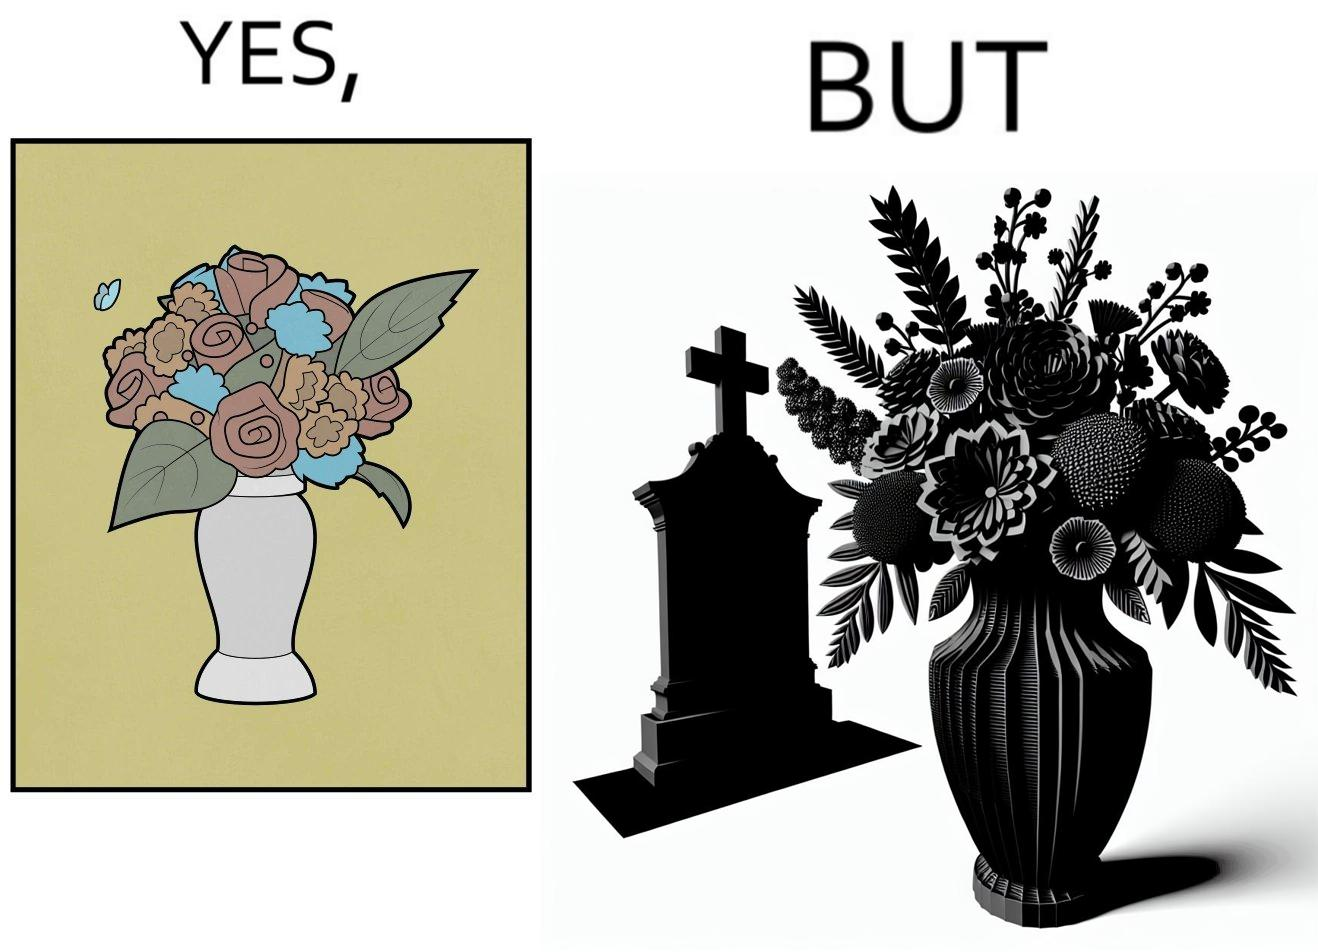Describe what you see in the left and right parts of this image. In the left part of the image: a beautiful vase of full of different beautiful flowers In the right part of the image: a beautiful vase of full of different beautiful flowers put in front of someone's grave stone 